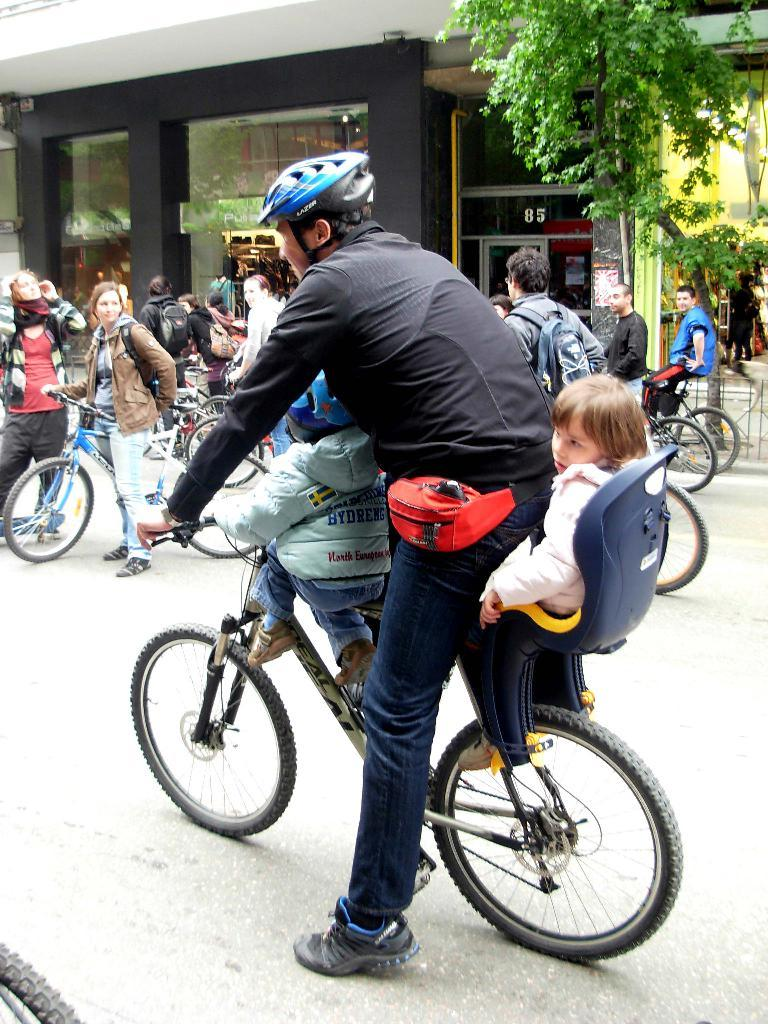What are the people in the image doing? The people in the image are riding bicycles. What natural element can be seen in the image? There is a tree in the image. What man-made structure is present in the image? There is a building in the image. How many giants can be seen in the image? There are no giants present in the image. What type of finger is being used to play the songs in the image? There is no mention of songs or fingers playing them in the image. 